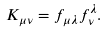<formula> <loc_0><loc_0><loc_500><loc_500>K _ { \mu \nu } = f _ { \mu \lambda } f ^ { \lambda } _ { \nu } .</formula> 